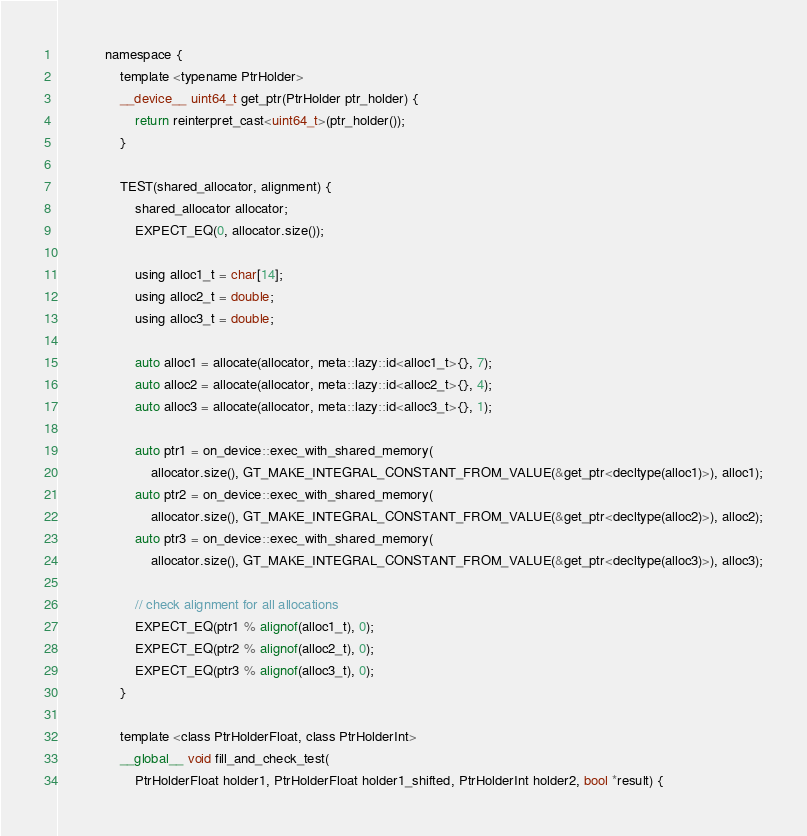<code> <loc_0><loc_0><loc_500><loc_500><_Cuda_>            namespace {
                template <typename PtrHolder>
                __device__ uint64_t get_ptr(PtrHolder ptr_holder) {
                    return reinterpret_cast<uint64_t>(ptr_holder());
                }

                TEST(shared_allocator, alignment) {
                    shared_allocator allocator;
                    EXPECT_EQ(0, allocator.size());

                    using alloc1_t = char[14];
                    using alloc2_t = double;
                    using alloc3_t = double;

                    auto alloc1 = allocate(allocator, meta::lazy::id<alloc1_t>{}, 7);
                    auto alloc2 = allocate(allocator, meta::lazy::id<alloc2_t>{}, 4);
                    auto alloc3 = allocate(allocator, meta::lazy::id<alloc3_t>{}, 1);

                    auto ptr1 = on_device::exec_with_shared_memory(
                        allocator.size(), GT_MAKE_INTEGRAL_CONSTANT_FROM_VALUE(&get_ptr<decltype(alloc1)>), alloc1);
                    auto ptr2 = on_device::exec_with_shared_memory(
                        allocator.size(), GT_MAKE_INTEGRAL_CONSTANT_FROM_VALUE(&get_ptr<decltype(alloc2)>), alloc2);
                    auto ptr3 = on_device::exec_with_shared_memory(
                        allocator.size(), GT_MAKE_INTEGRAL_CONSTANT_FROM_VALUE(&get_ptr<decltype(alloc3)>), alloc3);

                    // check alignment for all allocations
                    EXPECT_EQ(ptr1 % alignof(alloc1_t), 0);
                    EXPECT_EQ(ptr2 % alignof(alloc2_t), 0);
                    EXPECT_EQ(ptr3 % alignof(alloc3_t), 0);
                }

                template <class PtrHolderFloat, class PtrHolderInt>
                __global__ void fill_and_check_test(
                    PtrHolderFloat holder1, PtrHolderFloat holder1_shifted, PtrHolderInt holder2, bool *result) {</code> 